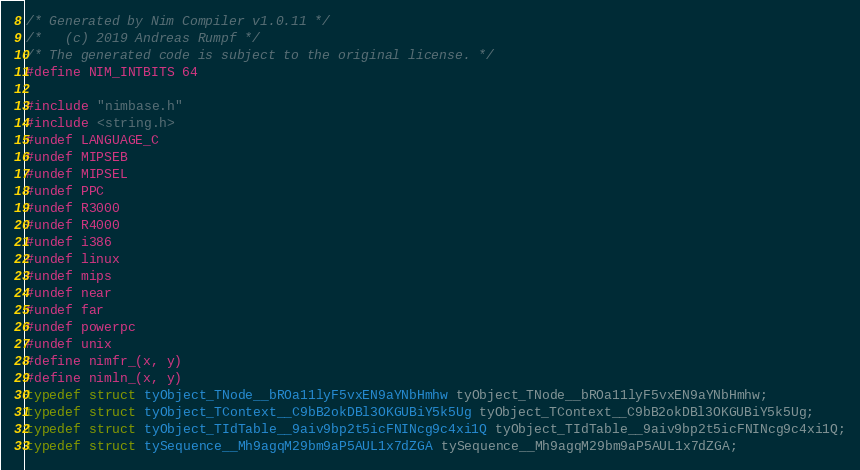<code> <loc_0><loc_0><loc_500><loc_500><_C_>/* Generated by Nim Compiler v1.0.11 */
/*   (c) 2019 Andreas Rumpf */
/* The generated code is subject to the original license. */
#define NIM_INTBITS 64

#include "nimbase.h"
#include <string.h>
#undef LANGUAGE_C
#undef MIPSEB
#undef MIPSEL
#undef PPC
#undef R3000
#undef R4000
#undef i386
#undef linux
#undef mips
#undef near
#undef far
#undef powerpc
#undef unix
#define nimfr_(x, y)
#define nimln_(x, y)
typedef struct tyObject_TNode__bROa11lyF5vxEN9aYNbHmhw tyObject_TNode__bROa11lyF5vxEN9aYNbHmhw;
typedef struct tyObject_TContext__C9bB2okDBl3OKGUBiY5k5Ug tyObject_TContext__C9bB2okDBl3OKGUBiY5k5Ug;
typedef struct tyObject_TIdTable__9aiv9bp2t5icFNINcg9c4xi1Q tyObject_TIdTable__9aiv9bp2t5icFNINcg9c4xi1Q;
typedef struct tySequence__Mh9agqM29bm9aP5AUL1x7dZGA tySequence__Mh9agqM29bm9aP5AUL1x7dZGA;</code> 